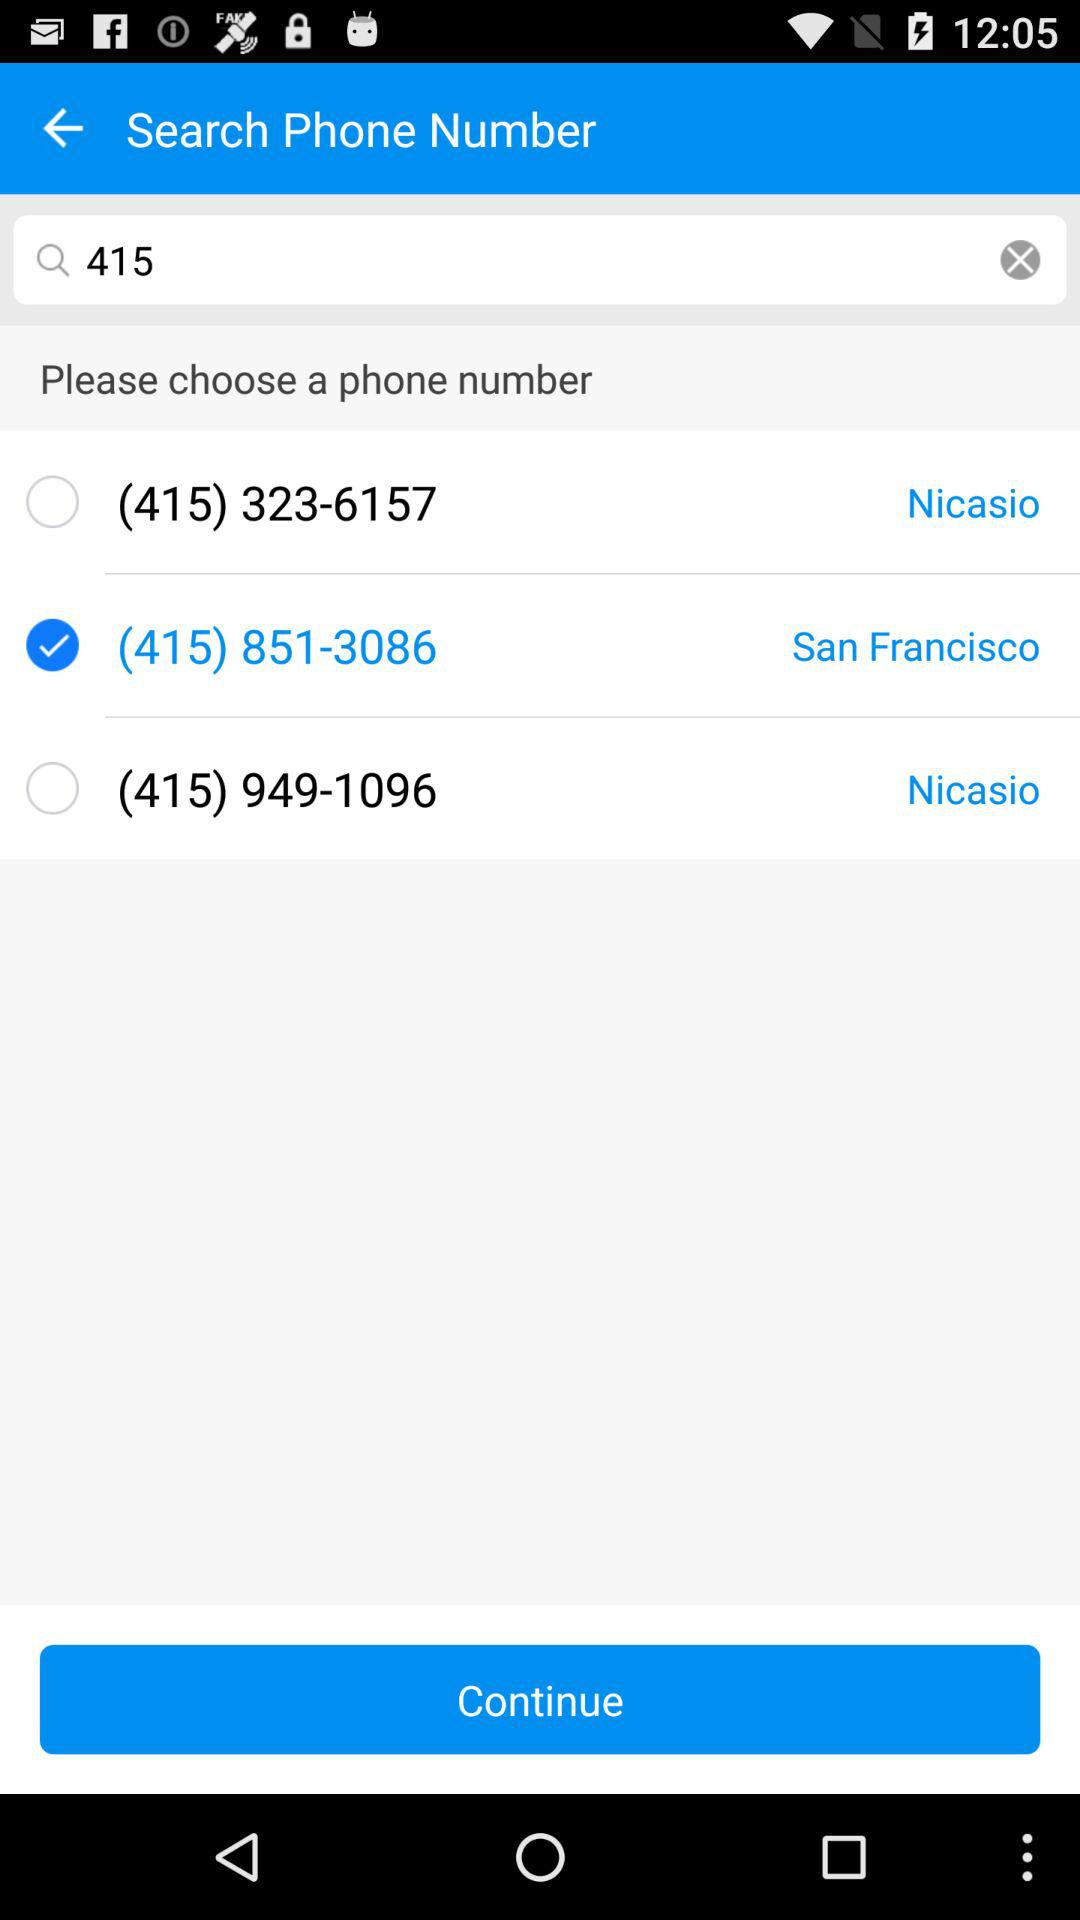What is the location for the selected phone number? The location for the selected phone number is San Francisco. 